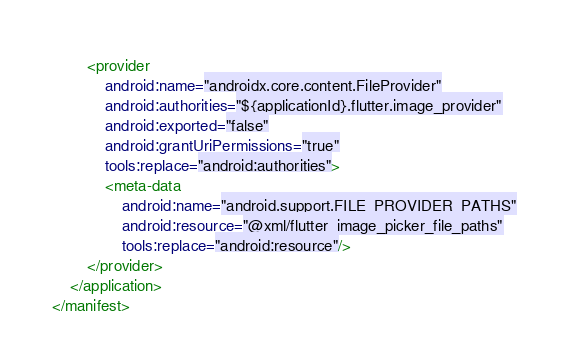<code> <loc_0><loc_0><loc_500><loc_500><_XML_>        <provider
            android:name="androidx.core.content.FileProvider"
            android:authorities="${applicationId}.flutter.image_provider"
            android:exported="false"
            android:grantUriPermissions="true"
            tools:replace="android:authorities">
            <meta-data
                android:name="android.support.FILE_PROVIDER_PATHS"
                android:resource="@xml/flutter_image_picker_file_paths"
                tools:replace="android:resource"/>
        </provider>
    </application>
</manifest></code> 